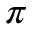<formula> <loc_0><loc_0><loc_500><loc_500>\pi</formula> 